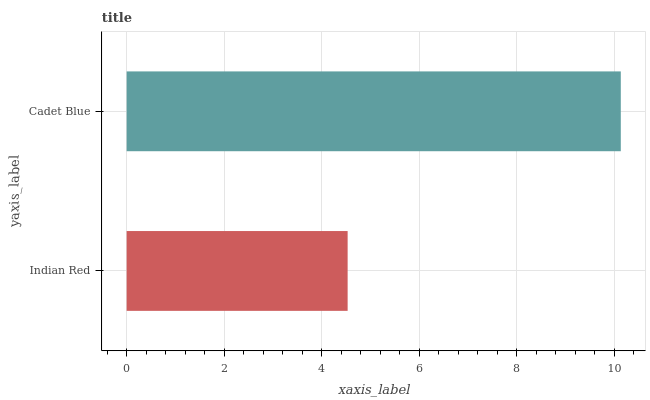Is Indian Red the minimum?
Answer yes or no. Yes. Is Cadet Blue the maximum?
Answer yes or no. Yes. Is Cadet Blue the minimum?
Answer yes or no. No. Is Cadet Blue greater than Indian Red?
Answer yes or no. Yes. Is Indian Red less than Cadet Blue?
Answer yes or no. Yes. Is Indian Red greater than Cadet Blue?
Answer yes or no. No. Is Cadet Blue less than Indian Red?
Answer yes or no. No. Is Cadet Blue the high median?
Answer yes or no. Yes. Is Indian Red the low median?
Answer yes or no. Yes. Is Indian Red the high median?
Answer yes or no. No. Is Cadet Blue the low median?
Answer yes or no. No. 